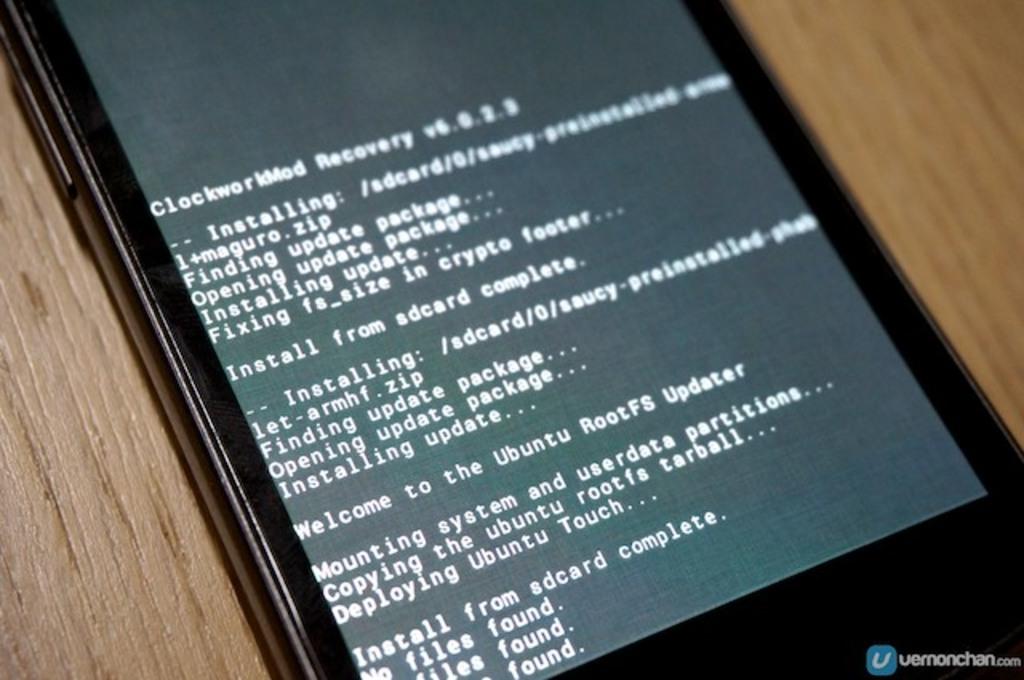What is the last word on the screen?
Provide a short and direct response. Found. What is the first line on the screen?
Ensure brevity in your answer.  Clockworkmod recovery. 